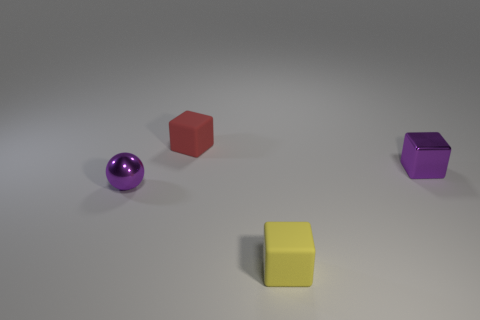Add 3 tiny purple objects. How many objects exist? 7 Subtract all blocks. How many objects are left? 1 Add 2 tiny purple balls. How many tiny purple balls are left? 3 Add 3 small cubes. How many small cubes exist? 6 Subtract 0 yellow balls. How many objects are left? 4 Subtract all small shiny balls. Subtract all small purple spheres. How many objects are left? 2 